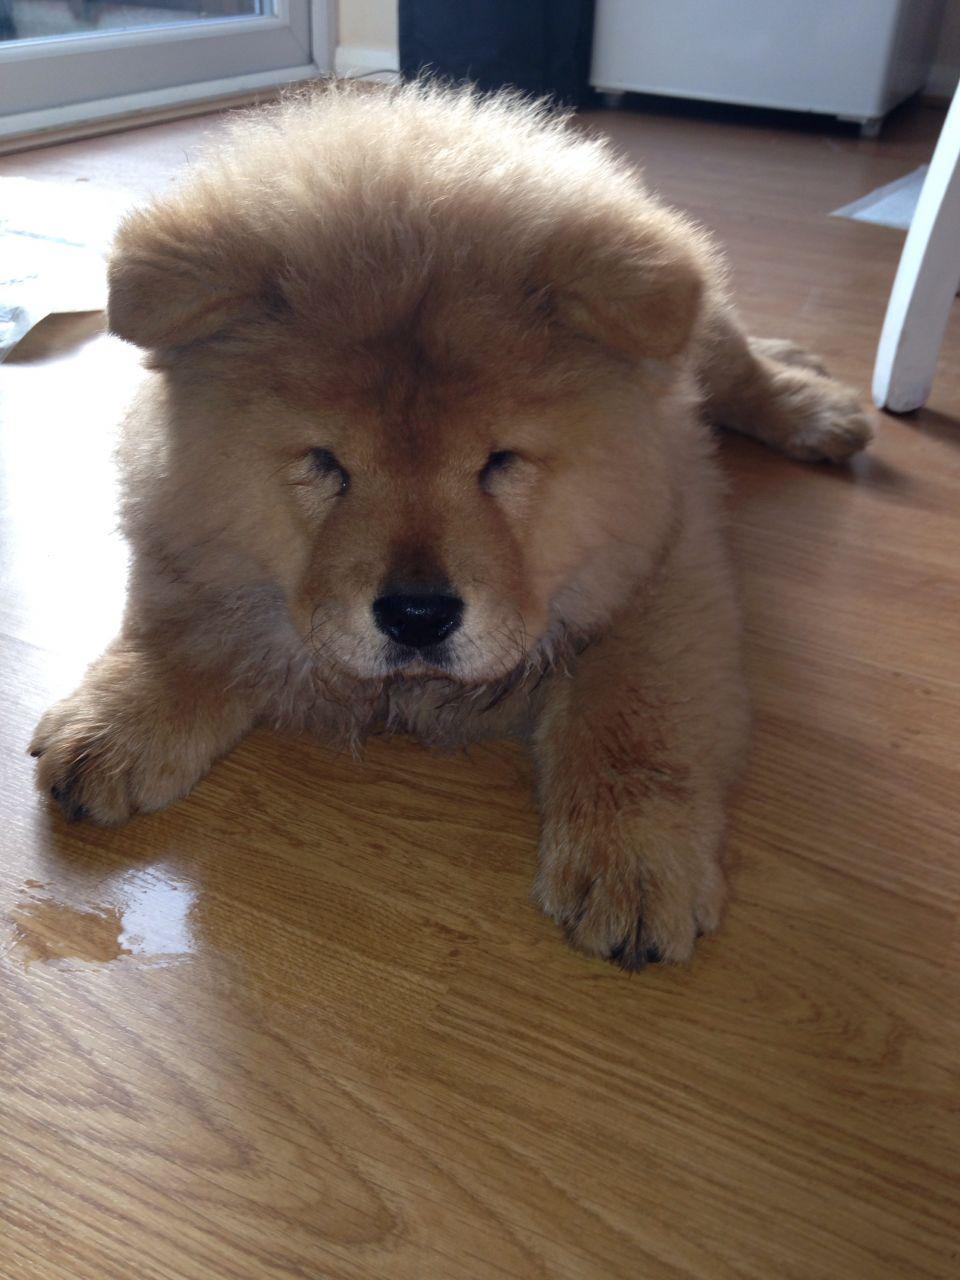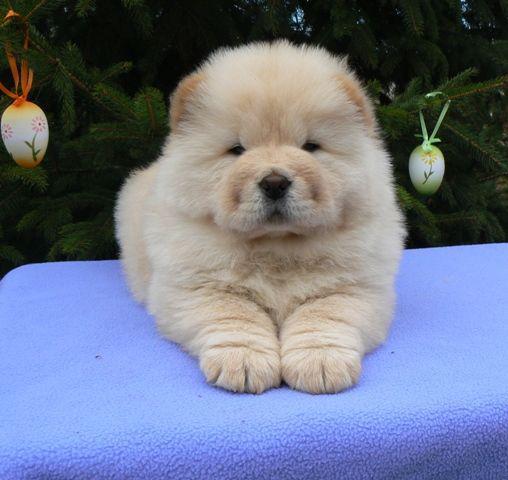The first image is the image on the left, the second image is the image on the right. Considering the images on both sides, is "The dog in the image on the left is lying down." valid? Answer yes or no. Yes. 